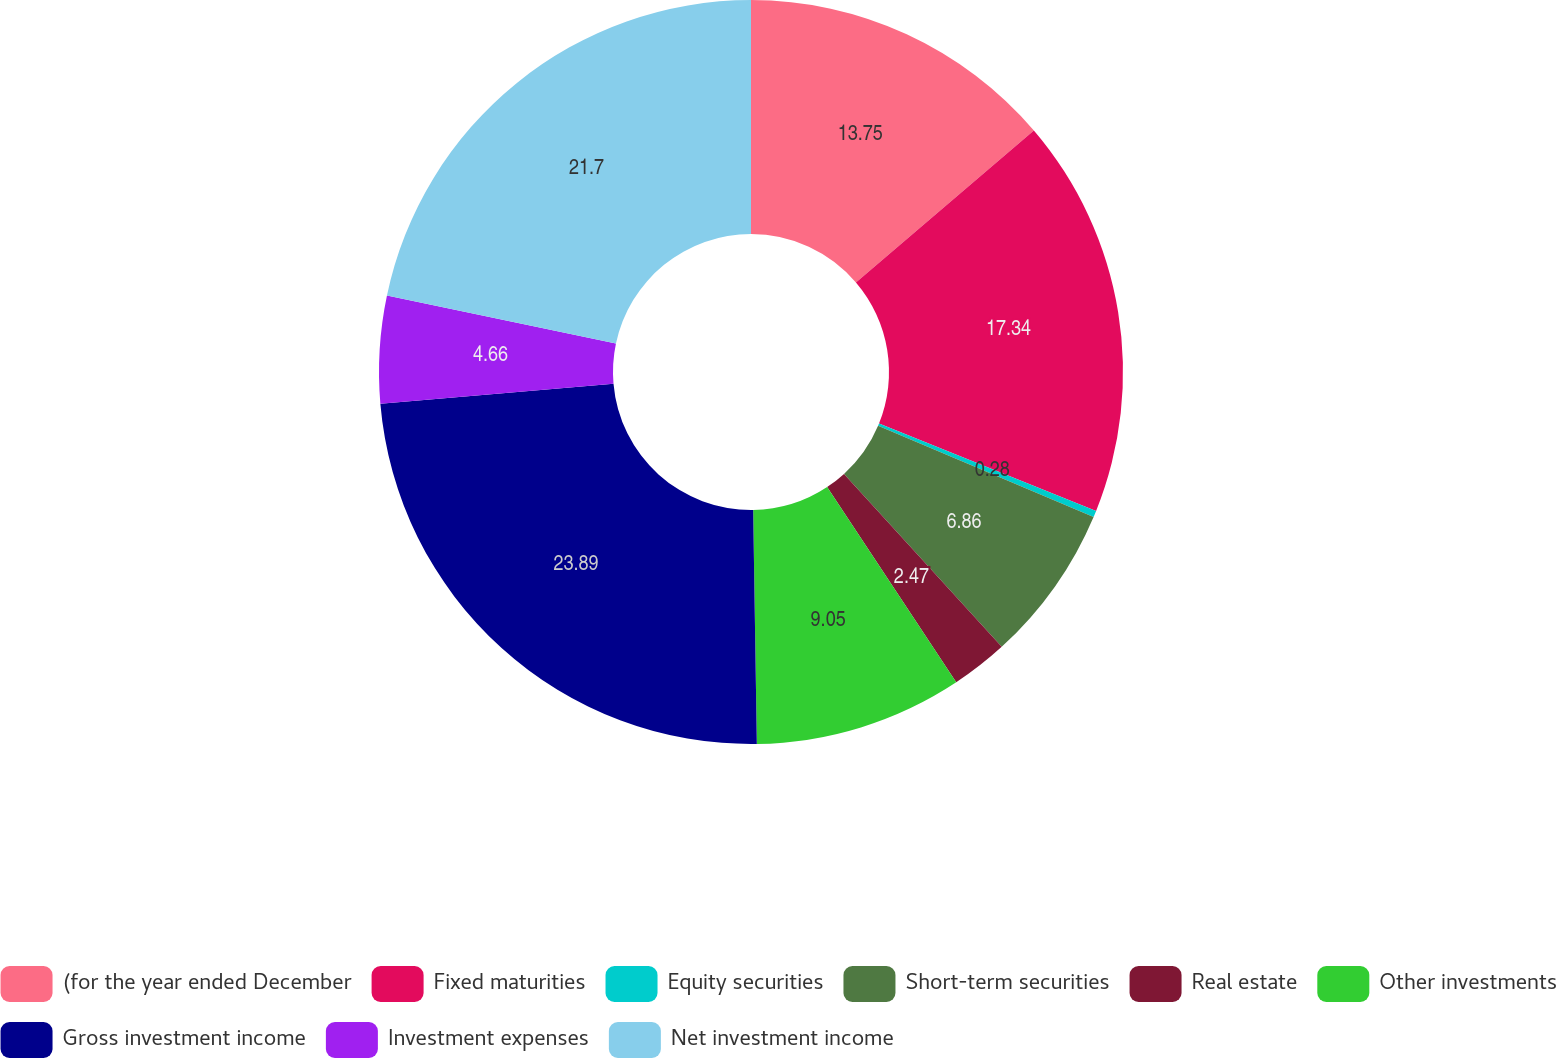Convert chart to OTSL. <chart><loc_0><loc_0><loc_500><loc_500><pie_chart><fcel>(for the year ended December<fcel>Fixed maturities<fcel>Equity securities<fcel>Short-term securities<fcel>Real estate<fcel>Other investments<fcel>Gross investment income<fcel>Investment expenses<fcel>Net investment income<nl><fcel>13.75%<fcel>17.34%<fcel>0.28%<fcel>6.86%<fcel>2.47%<fcel>9.05%<fcel>23.89%<fcel>4.66%<fcel>21.7%<nl></chart> 